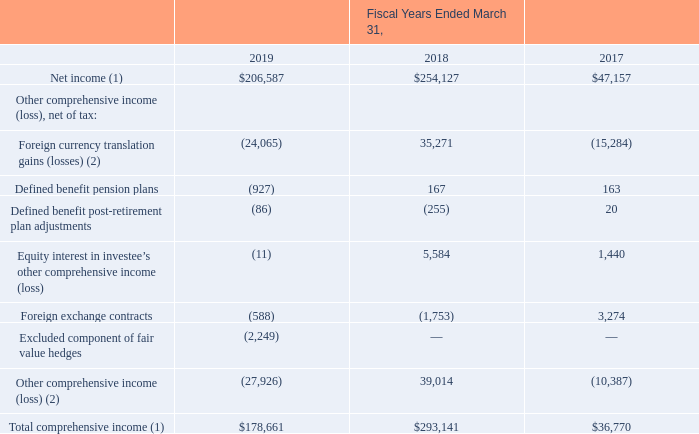Consolidated Statements of Comprehensive Income (Loss)
(Amounts in thousands)
(1) Fiscal years ended March 31, 2018 and 2017 adjusted due to the adoption of ASC 606.
(2) Fiscal year ended March 31, 2018 adjusted due to the adoption of ASC 606.
See accompanying notes to consolidated financial statements.
Which years does the table provide information for the Consolidated Statements of Comprehensive Income (Loss)? 2019, 2018, 2017. What was the net income in 2017?
Answer scale should be: thousand. 47,157. What was the Defined benefit pension plans in 2019?
Answer scale should be: thousand. (927). How many years did net income exceed $100,000 thousand? 2019##2018
Answer: 2. What was the change in Defined benefit post-retirement plan adjustments between 2017 and 2019?
Answer scale should be: thousand. -86-20
Answer: -106. What was the percentage change in the Total comprehensive income between 2018 and 2019?
Answer scale should be: percent. (178,661-293,141)/293,141
Answer: -39.05. 